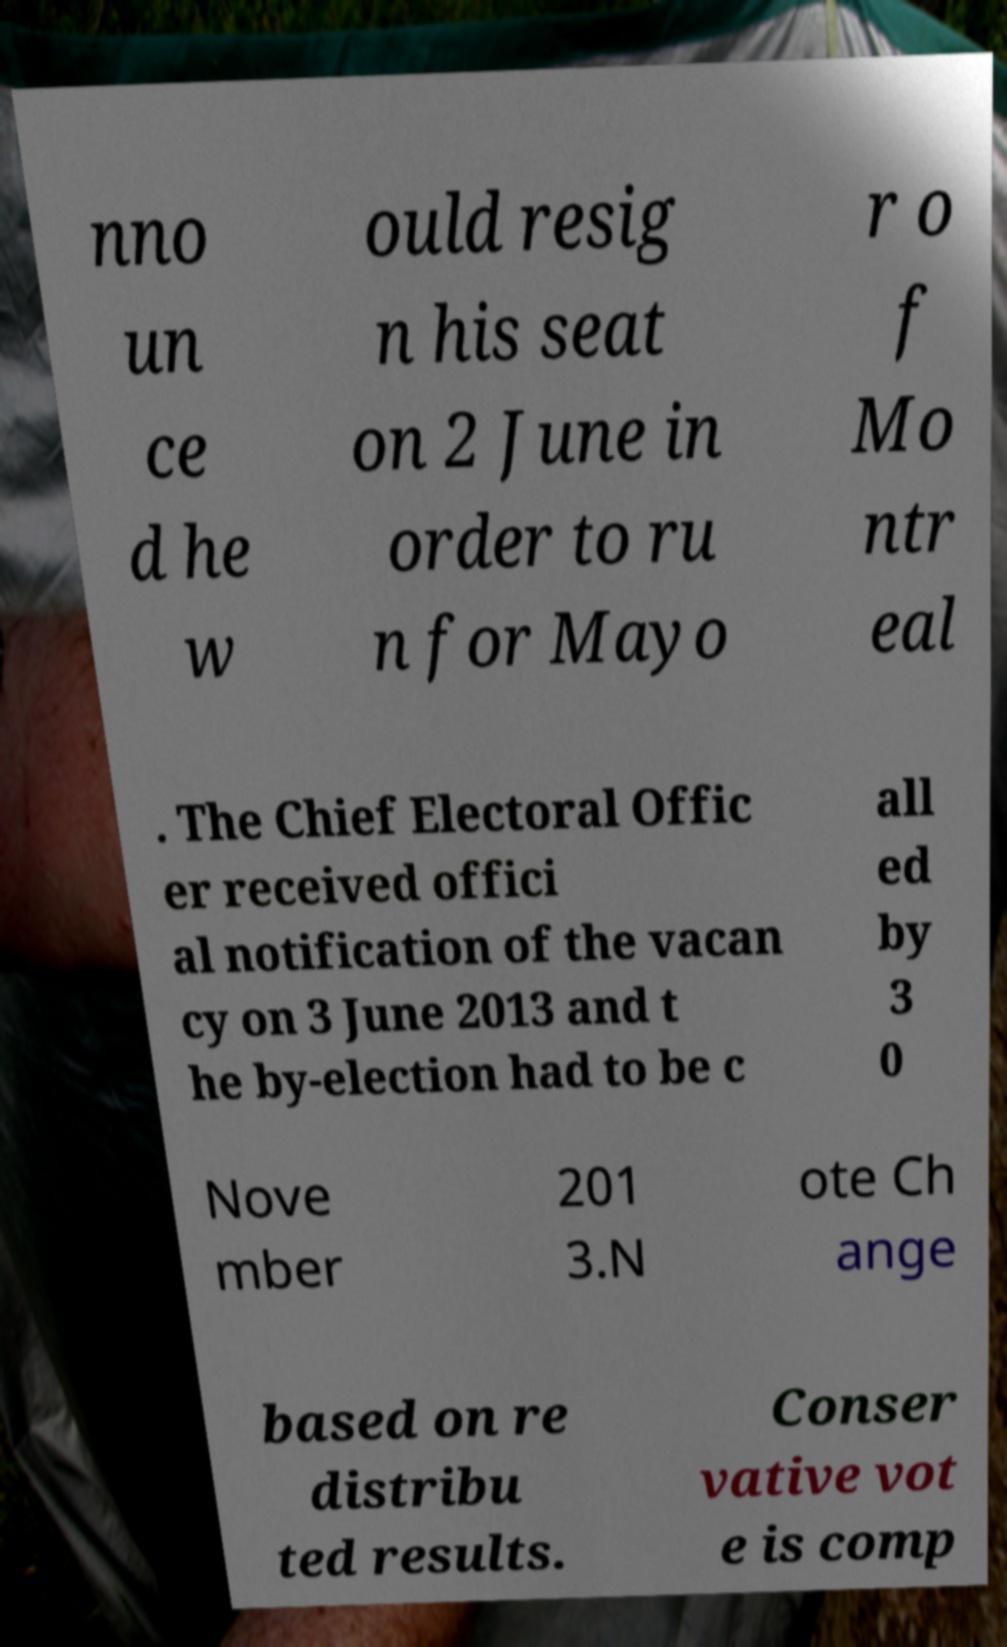Could you assist in decoding the text presented in this image and type it out clearly? nno un ce d he w ould resig n his seat on 2 June in order to ru n for Mayo r o f Mo ntr eal . The Chief Electoral Offic er received offici al notification of the vacan cy on 3 June 2013 and t he by-election had to be c all ed by 3 0 Nove mber 201 3.N ote Ch ange based on re distribu ted results. Conser vative vot e is comp 